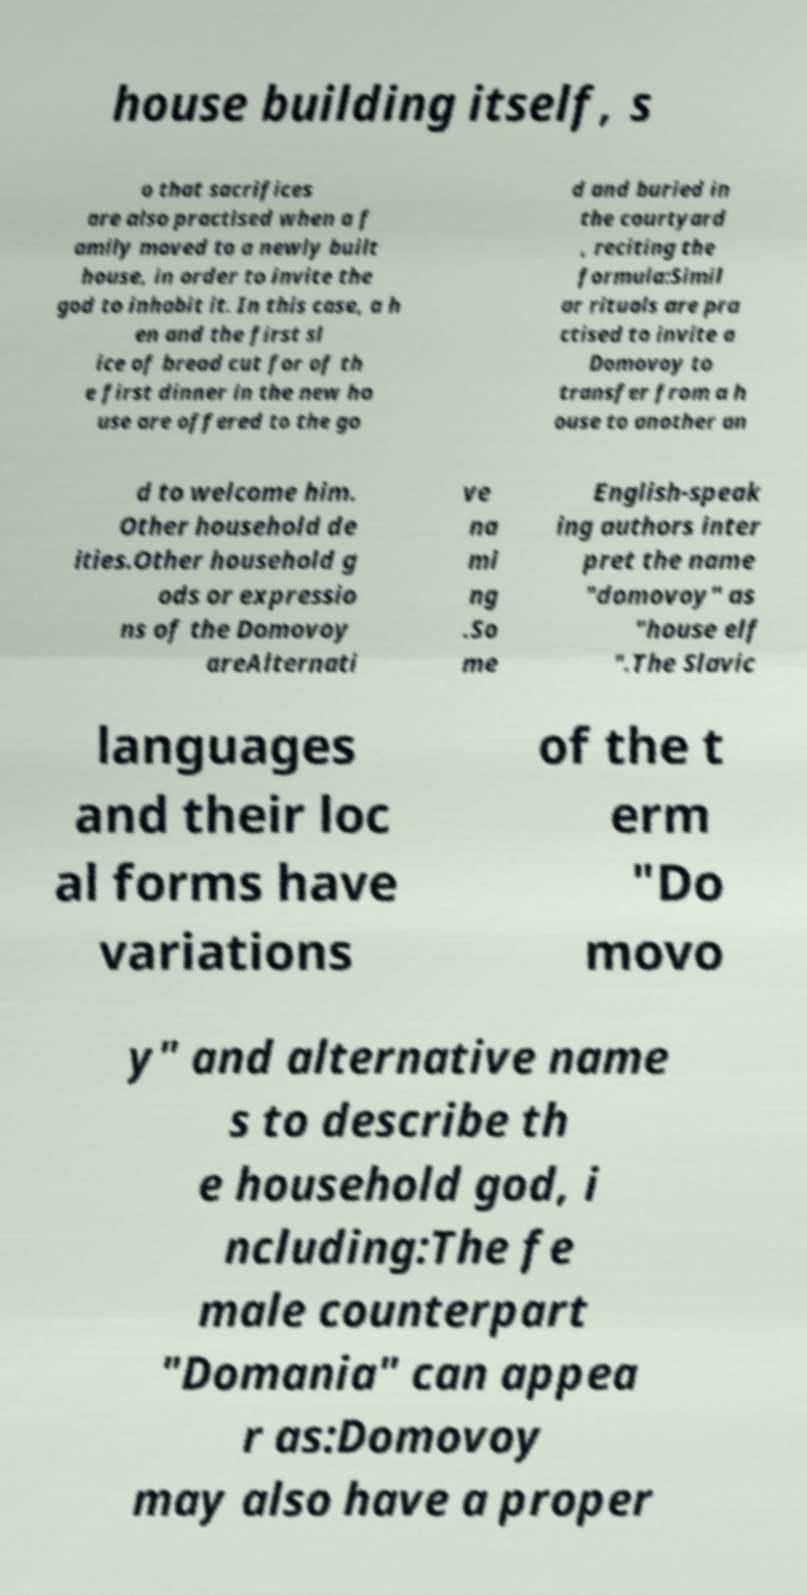I need the written content from this picture converted into text. Can you do that? house building itself, s o that sacrifices are also practised when a f amily moved to a newly built house, in order to invite the god to inhabit it. In this case, a h en and the first sl ice of bread cut for of th e first dinner in the new ho use are offered to the go d and buried in the courtyard , reciting the formula:Simil ar rituals are pra ctised to invite a Domovoy to transfer from a h ouse to another an d to welcome him. Other household de ities.Other household g ods or expressio ns of the Domovoy areAlternati ve na mi ng .So me English-speak ing authors inter pret the name "domovoy" as "house elf ".The Slavic languages and their loc al forms have variations of the t erm "Do movo y" and alternative name s to describe th e household god, i ncluding:The fe male counterpart "Domania" can appea r as:Domovoy may also have a proper 